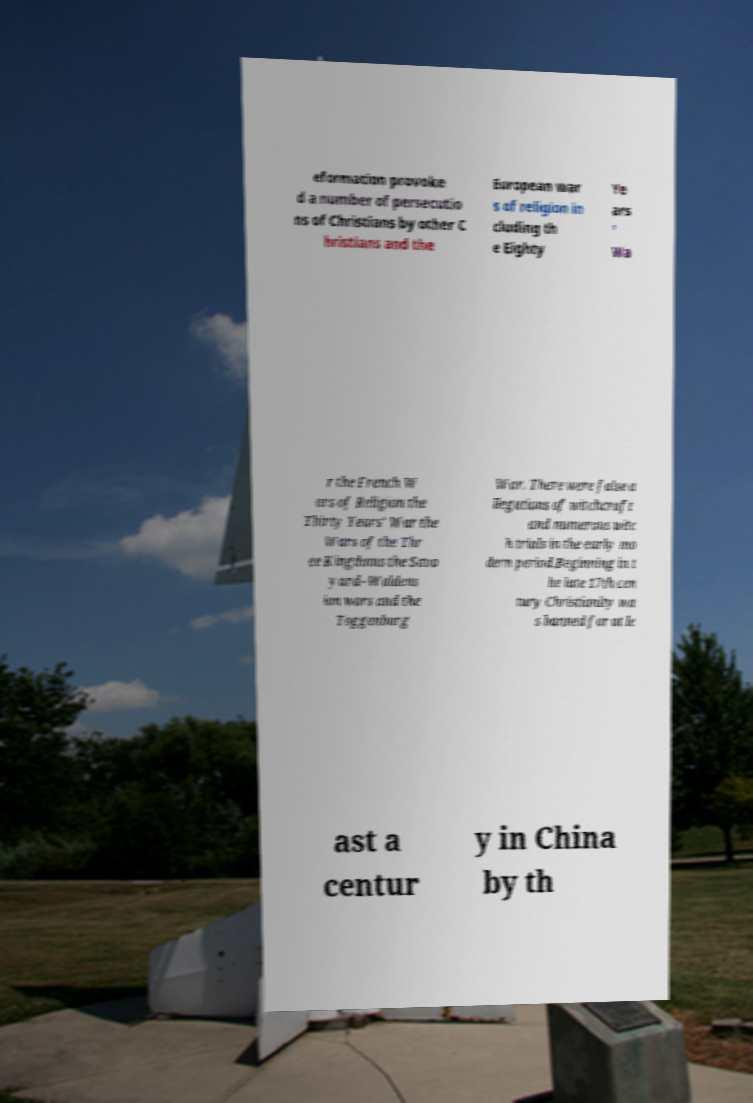Can you accurately transcribe the text from the provided image for me? eformation provoke d a number of persecutio ns of Christians by other C hristians and the European war s of religion in cluding th e Eighty Ye ars ' Wa r the French W ars of Religion the Thirty Years' War the Wars of the Thr ee Kingdoms the Savo yard–Waldens ian wars and the Toggenburg War. There were false a llegations of witchcraft and numerous witc h trials in the early mo dern period.Beginning in t he late 17th cen tury Christianity wa s banned for at le ast a centur y in China by th 